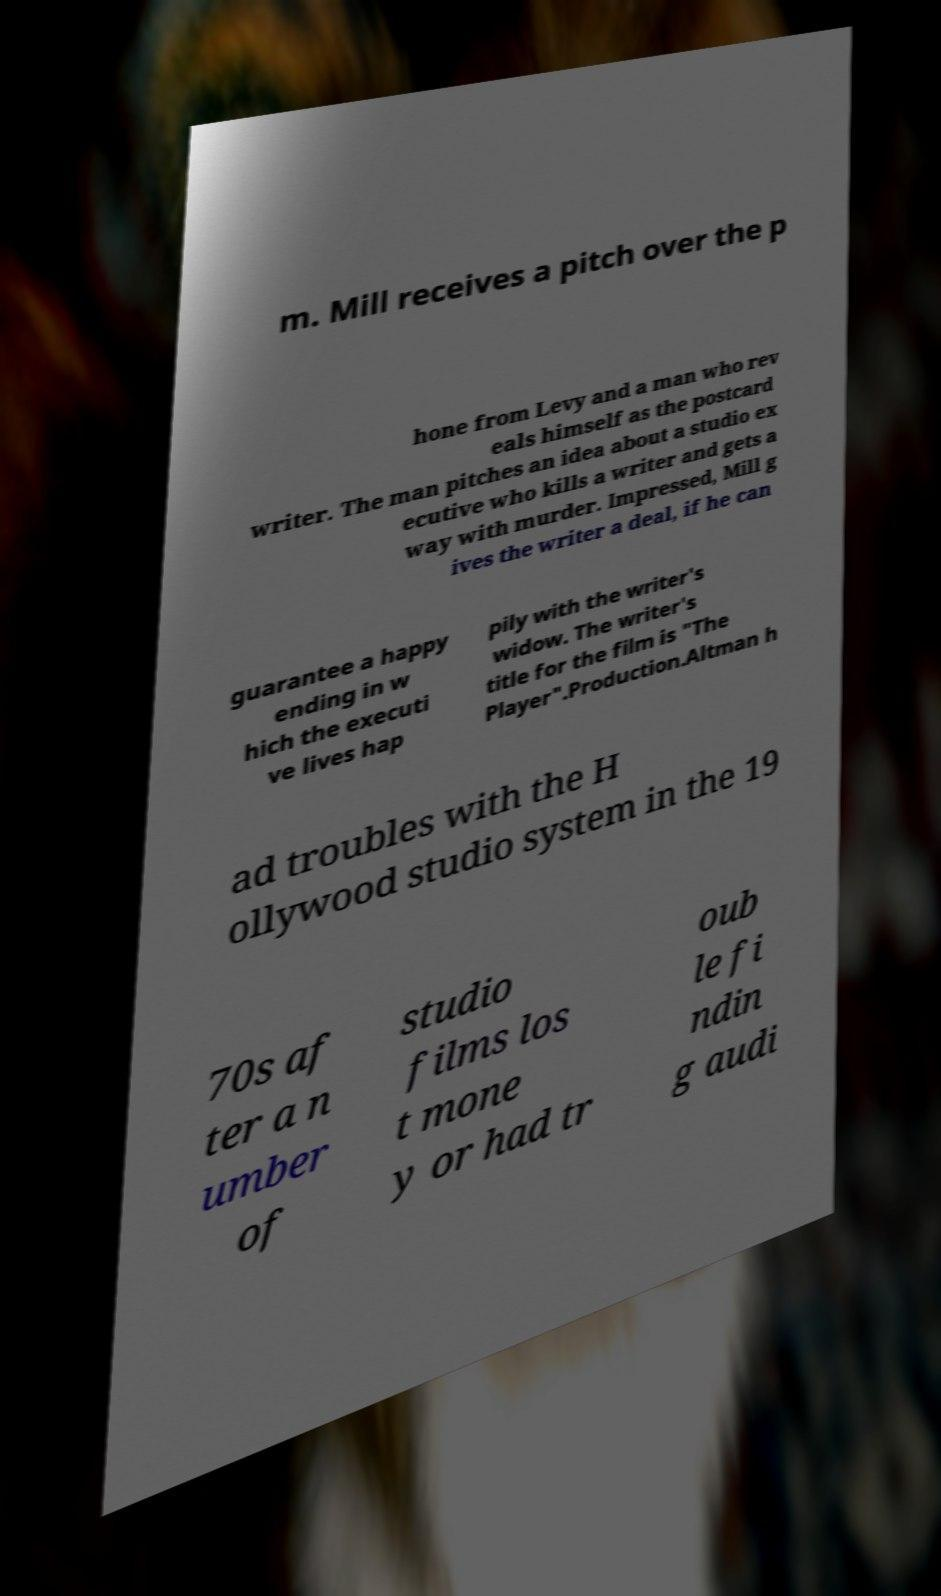I need the written content from this picture converted into text. Can you do that? m. Mill receives a pitch over the p hone from Levy and a man who rev eals himself as the postcard writer. The man pitches an idea about a studio ex ecutive who kills a writer and gets a way with murder. Impressed, Mill g ives the writer a deal, if he can guarantee a happy ending in w hich the executi ve lives hap pily with the writer's widow. The writer's title for the film is "The Player".Production.Altman h ad troubles with the H ollywood studio system in the 19 70s af ter a n umber of studio films los t mone y or had tr oub le fi ndin g audi 